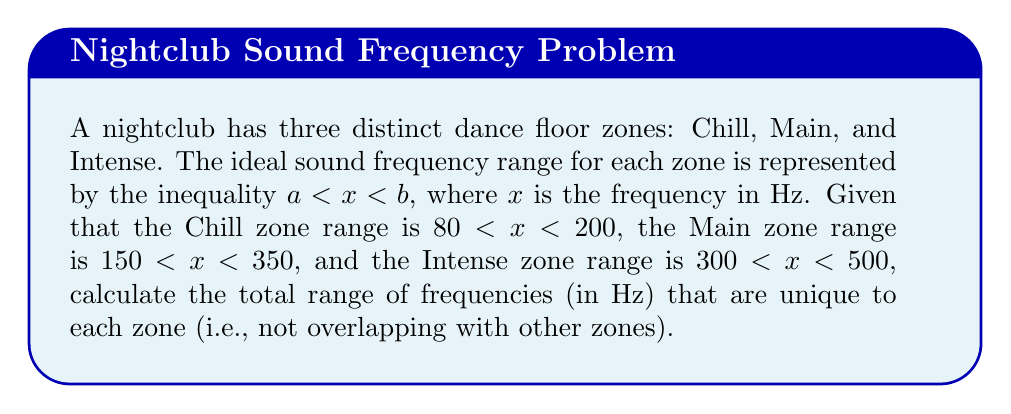Could you help me with this problem? To solve this problem, we need to identify the non-overlapping ranges for each zone:

1. Chill zone unique range: $80 < x \leq 150$
2. Main zone unique range: $200 < x \leq 300$
3. Intense zone unique range: $350 < x < 500$

Now, let's calculate the length of each unique range:

1. Chill zone: $150 - 80 = 70$ Hz
2. Main zone: $300 - 200 = 100$ Hz
3. Intense zone: $500 - 350 = 150$ Hz

To find the total range of frequencies unique to each zone, we sum these individual ranges:

$$\text{Total unique range} = 70 + 100 + 150 = 320\text{ Hz}$$
Answer: 320 Hz 